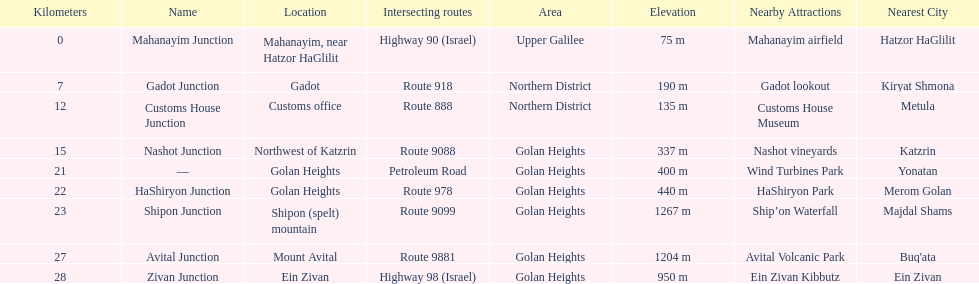What is the total kilometers that separates the mahanayim junction and the shipon junction? 23. 